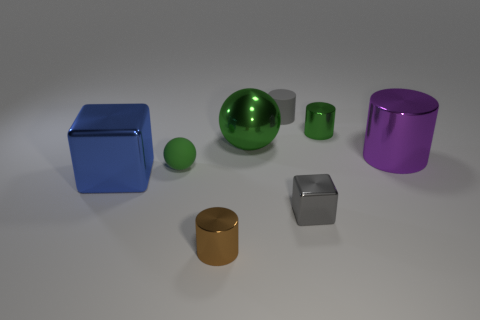What materials do these objects appear to be made of? The objects in the image seem to have a metallic sheen, indicating that they could be made of materials like metal or polished plastic with a reflective coating to give a metallic appearance. Can you describe the lighting in the scene? The scene is illuminated by a soft, diffused light source above the scene, producing gentle shadows underneath the objects, emphasizing their shapes and the smoothness of their surfaces. 